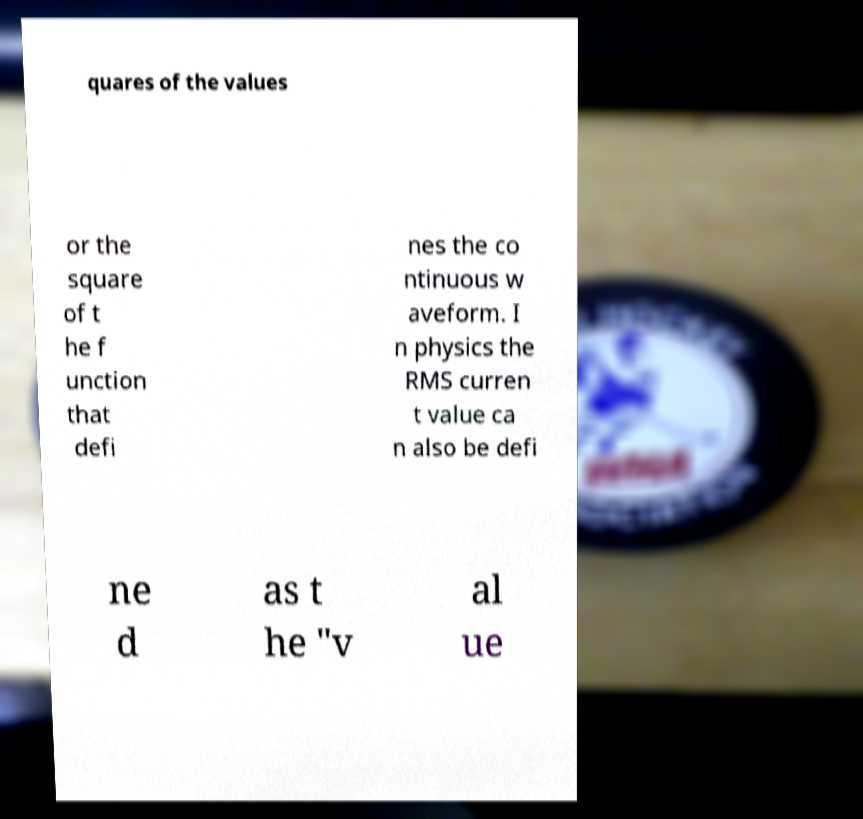What messages or text are displayed in this image? I need them in a readable, typed format. quares of the values or the square of t he f unction that defi nes the co ntinuous w aveform. I n physics the RMS curren t value ca n also be defi ne d as t he "v al ue 